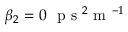Convert formula to latex. <formula><loc_0><loc_0><loc_500><loc_500>\beta _ { 2 } = 0 p s ^ { 2 } m ^ { - 1 }</formula> 